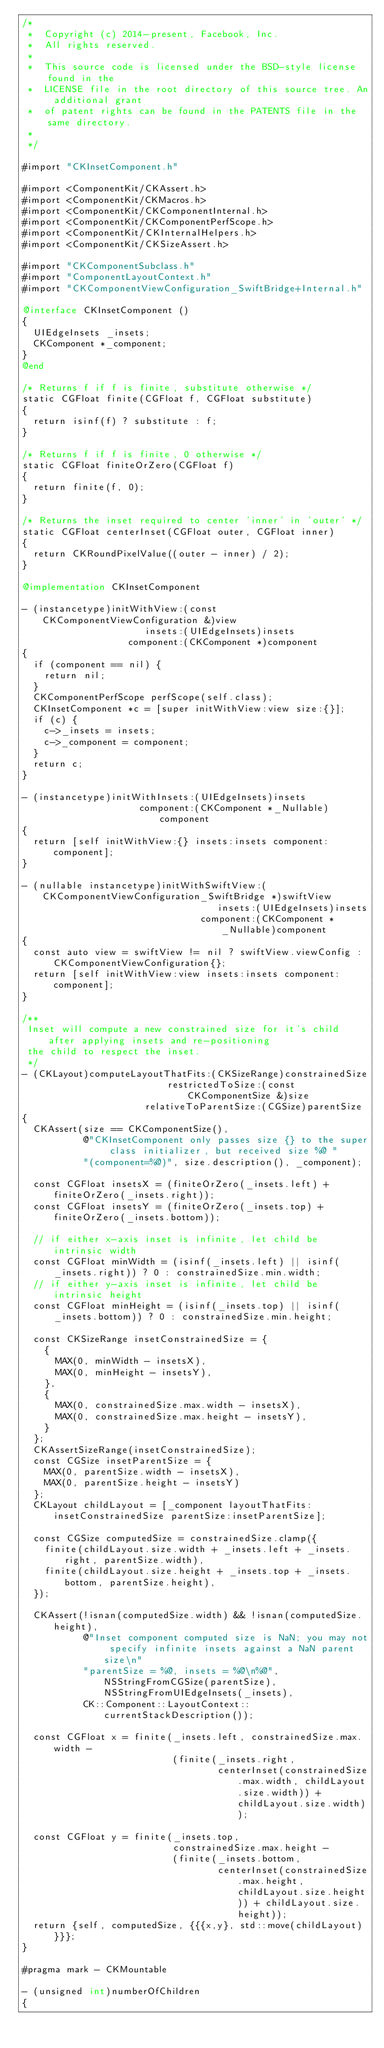<code> <loc_0><loc_0><loc_500><loc_500><_ObjectiveC_>/*
 *  Copyright (c) 2014-present, Facebook, Inc.
 *  All rights reserved.
 *
 *  This source code is licensed under the BSD-style license found in the
 *  LICENSE file in the root directory of this source tree. An additional grant
 *  of patent rights can be found in the PATENTS file in the same directory.
 *
 */

#import "CKInsetComponent.h"

#import <ComponentKit/CKAssert.h>
#import <ComponentKit/CKMacros.h>
#import <ComponentKit/CKComponentInternal.h>
#import <ComponentKit/CKComponentPerfScope.h>
#import <ComponentKit/CKInternalHelpers.h>
#import <ComponentKit/CKSizeAssert.h>

#import "CKComponentSubclass.h"
#import "ComponentLayoutContext.h"
#import "CKComponentViewConfiguration_SwiftBridge+Internal.h"

@interface CKInsetComponent ()
{
  UIEdgeInsets _insets;
  CKComponent *_component;
}
@end

/* Returns f if f is finite, substitute otherwise */
static CGFloat finite(CGFloat f, CGFloat substitute)
{
  return isinf(f) ? substitute : f;
}

/* Returns f if f is finite, 0 otherwise */
static CGFloat finiteOrZero(CGFloat f)
{
  return finite(f, 0);
}

/* Returns the inset required to center 'inner' in 'outer' */
static CGFloat centerInset(CGFloat outer, CGFloat inner)
{
  return CKRoundPixelValue((outer - inner) / 2);
}

@implementation CKInsetComponent

- (instancetype)initWithView:(const CKComponentViewConfiguration &)view
                      insets:(UIEdgeInsets)insets
                   component:(CKComponent *)component
{
  if (component == nil) {
    return nil;
  }
  CKComponentPerfScope perfScope(self.class);
  CKInsetComponent *c = [super initWithView:view size:{}];
  if (c) {
    c->_insets = insets;
    c->_component = component;
  }
  return c;
}

- (instancetype)initWithInsets:(UIEdgeInsets)insets
                     component:(CKComponent *_Nullable)component
{
  return [self initWithView:{} insets:insets component:component];
}

- (nullable instancetype)initWithSwiftView:(CKComponentViewConfiguration_SwiftBridge *)swiftView
                                   insets:(UIEdgeInsets)insets
                                component:(CKComponent *_Nullable)component
{
  const auto view = swiftView != nil ? swiftView.viewConfig : CKComponentViewConfiguration{};
  return [self initWithView:view insets:insets component:component];
}

/**
 Inset will compute a new constrained size for it's child after applying insets and re-positioning
 the child to respect the inset.
 */
- (CKLayout)computeLayoutThatFits:(CKSizeRange)constrainedSize
                          restrictedToSize:(const CKComponentSize &)size
                      relativeToParentSize:(CGSize)parentSize
{
  CKAssert(size == CKComponentSize(),
           @"CKInsetComponent only passes size {} to the super class initializer, but received size %@ "
           "(component=%@)", size.description(), _component);

  const CGFloat insetsX = (finiteOrZero(_insets.left) + finiteOrZero(_insets.right));
  const CGFloat insetsY = (finiteOrZero(_insets.top) + finiteOrZero(_insets.bottom));

  // if either x-axis inset is infinite, let child be intrinsic width
  const CGFloat minWidth = (isinf(_insets.left) || isinf(_insets.right)) ? 0 : constrainedSize.min.width;
  // if either y-axis inset is infinite, let child be intrinsic height
  const CGFloat minHeight = (isinf(_insets.top) || isinf(_insets.bottom)) ? 0 : constrainedSize.min.height;

  const CKSizeRange insetConstrainedSize = {
    {
      MAX(0, minWidth - insetsX),
      MAX(0, minHeight - insetsY),
    },
    {
      MAX(0, constrainedSize.max.width - insetsX),
      MAX(0, constrainedSize.max.height - insetsY),
    }
  };
  CKAssertSizeRange(insetConstrainedSize);
  const CGSize insetParentSize = {
    MAX(0, parentSize.width - insetsX),
    MAX(0, parentSize.height - insetsY)
  };
  CKLayout childLayout = [_component layoutThatFits:insetConstrainedSize parentSize:insetParentSize];

  const CGSize computedSize = constrainedSize.clamp({
    finite(childLayout.size.width + _insets.left + _insets.right, parentSize.width),
    finite(childLayout.size.height + _insets.top + _insets.bottom, parentSize.height),
  });

  CKAssert(!isnan(computedSize.width) && !isnan(computedSize.height),
           @"Inset component computed size is NaN; you may not specify infinite insets against a NaN parent size\n"
           "parentSize = %@, insets = %@\n%@", NSStringFromCGSize(parentSize), NSStringFromUIEdgeInsets(_insets),
           CK::Component::LayoutContext::currentStackDescription());

  const CGFloat x = finite(_insets.left, constrainedSize.max.width -
                           (finite(_insets.right,
                                   centerInset(constrainedSize.max.width, childLayout.size.width)) + childLayout.size.width));

  const CGFloat y = finite(_insets.top,
                           constrainedSize.max.height -
                           (finite(_insets.bottom,
                                   centerInset(constrainedSize.max.height, childLayout.size.height)) + childLayout.size.height));
  return {self, computedSize, {{{x,y}, std::move(childLayout)}}};
}

#pragma mark - CKMountable

- (unsigned int)numberOfChildren
{</code> 